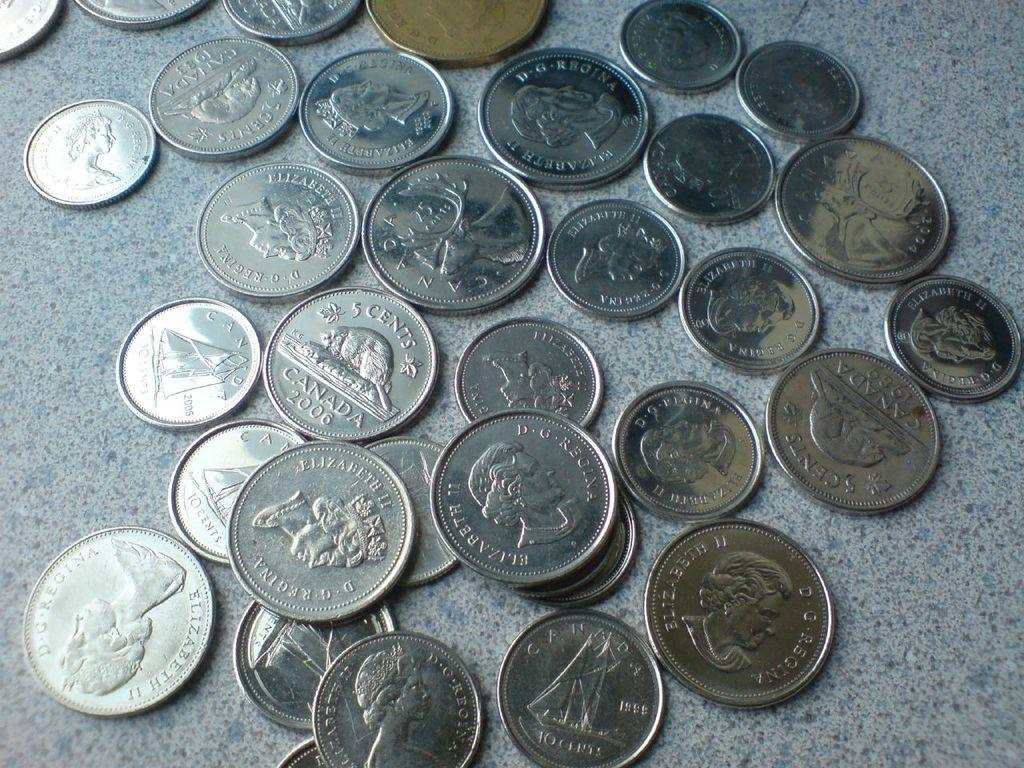<image>
Create a compact narrative representing the image presented. Various coins from Canada from the late 1900's. 